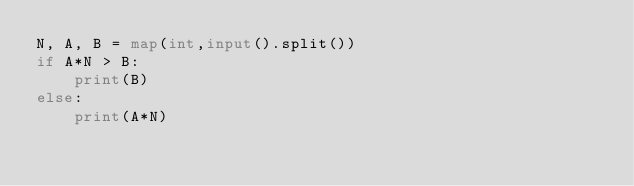Convert code to text. <code><loc_0><loc_0><loc_500><loc_500><_Python_>N, A, B = map(int,input().split())
if A*N > B:
    print(B)
else:
    print(A*N)</code> 